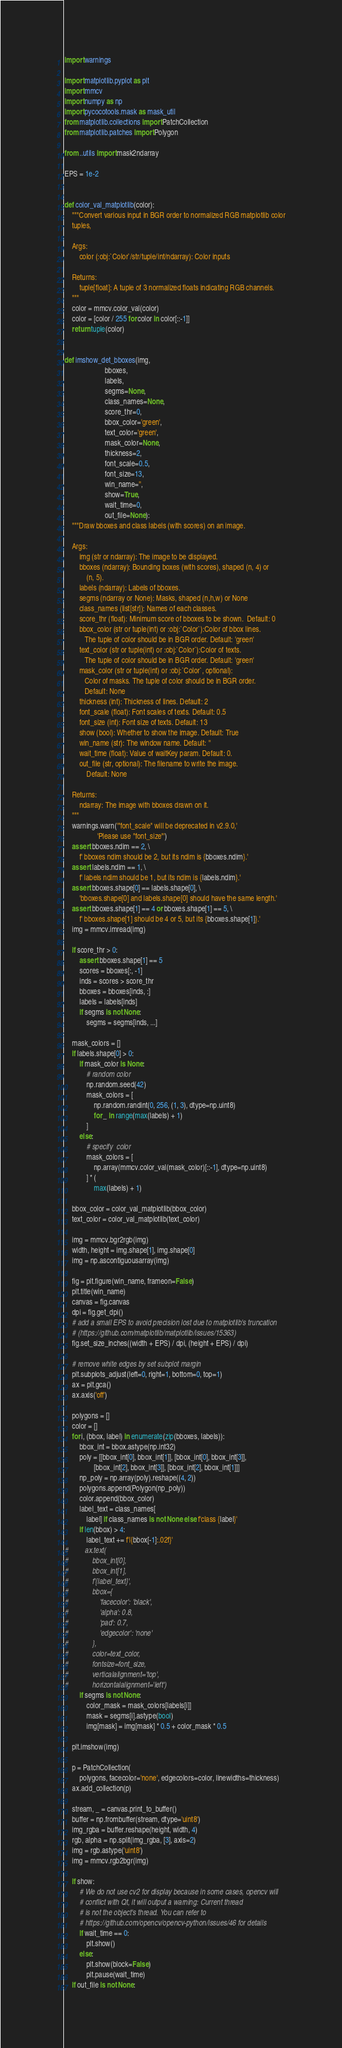Convert code to text. <code><loc_0><loc_0><loc_500><loc_500><_Python_>import warnings

import matplotlib.pyplot as plt
import mmcv
import numpy as np
import pycocotools.mask as mask_util
from matplotlib.collections import PatchCollection
from matplotlib.patches import Polygon

from ..utils import mask2ndarray

EPS = 1e-2


def color_val_matplotlib(color):
    """Convert various input in BGR order to normalized RGB matplotlib color
    tuples,

    Args:
        color (:obj:`Color`/str/tuple/int/ndarray): Color inputs

    Returns:
        tuple[float]: A tuple of 3 normalized floats indicating RGB channels.
    """
    color = mmcv.color_val(color)
    color = [color / 255 for color in color[::-1]]
    return tuple(color)


def imshow_det_bboxes(img,
                      bboxes,
                      labels,
                      segms=None,
                      class_names=None,
                      score_thr=0,
                      bbox_color='green',
                      text_color='green',
                      mask_color=None,
                      thickness=2,
                      font_scale=0.5,
                      font_size=13,
                      win_name='',
                      show=True,
                      wait_time=0,
                      out_file=None):
    """Draw bboxes and class labels (with scores) on an image.

    Args:
        img (str or ndarray): The image to be displayed.
        bboxes (ndarray): Bounding boxes (with scores), shaped (n, 4) or
            (n, 5).
        labels (ndarray): Labels of bboxes.
        segms (ndarray or None): Masks, shaped (n,h,w) or None
        class_names (list[str]): Names of each classes.
        score_thr (float): Minimum score of bboxes to be shown.  Default: 0
        bbox_color (str or tuple(int) or :obj:`Color`):Color of bbox lines.
           The tuple of color should be in BGR order. Default: 'green'
        text_color (str or tuple(int) or :obj:`Color`):Color of texts.
           The tuple of color should be in BGR order. Default: 'green'
        mask_color (str or tuple(int) or :obj:`Color`, optional):
           Color of masks. The tuple of color should be in BGR order.
           Default: None
        thickness (int): Thickness of lines. Default: 2
        font_scale (float): Font scales of texts. Default: 0.5
        font_size (int): Font size of texts. Default: 13
        show (bool): Whether to show the image. Default: True
        win_name (str): The window name. Default: ''
        wait_time (float): Value of waitKey param. Default: 0.
        out_file (str, optional): The filename to write the image.
            Default: None

    Returns:
        ndarray: The image with bboxes drawn on it.
    """
    warnings.warn('"font_scale" will be deprecated in v2.9.0,'
                  'Please use "font_size"')
    assert bboxes.ndim == 2, \
        f' bboxes ndim should be 2, but its ndim is {bboxes.ndim}.'
    assert labels.ndim == 1, \
        f' labels ndim should be 1, but its ndim is {labels.ndim}.'
    assert bboxes.shape[0] == labels.shape[0], \
        'bboxes.shape[0] and labels.shape[0] should have the same length.'
    assert bboxes.shape[1] == 4 or bboxes.shape[1] == 5, \
        f' bboxes.shape[1] should be 4 or 5, but its {bboxes.shape[1]}.'
    img = mmcv.imread(img)

    if score_thr > 0:
        assert bboxes.shape[1] == 5
        scores = bboxes[:, -1]
        inds = scores > score_thr
        bboxes = bboxes[inds, :]
        labels = labels[inds]
        if segms is not None:
            segms = segms[inds, ...]

    mask_colors = []
    if labels.shape[0] > 0:
        if mask_color is None:
            # random color
            np.random.seed(42)
            mask_colors = [
                np.random.randint(0, 256, (1, 3), dtype=np.uint8)
                for _ in range(max(labels) + 1)
            ]
        else:
            # specify  color
            mask_colors = [
                np.array(mmcv.color_val(mask_color)[::-1], dtype=np.uint8)
            ] * (
                max(labels) + 1)

    bbox_color = color_val_matplotlib(bbox_color)
    text_color = color_val_matplotlib(text_color)

    img = mmcv.bgr2rgb(img)
    width, height = img.shape[1], img.shape[0]
    img = np.ascontiguousarray(img)

    fig = plt.figure(win_name, frameon=False)
    plt.title(win_name)
    canvas = fig.canvas
    dpi = fig.get_dpi()
    # add a small EPS to avoid precision lost due to matplotlib's truncation
    # (https://github.com/matplotlib/matplotlib/issues/15363)
    fig.set_size_inches((width + EPS) / dpi, (height + EPS) / dpi)

    # remove white edges by set subplot margin
    plt.subplots_adjust(left=0, right=1, bottom=0, top=1)
    ax = plt.gca()
    ax.axis('off')

    polygons = []
    color = []
    for i, (bbox, label) in enumerate(zip(bboxes, labels)):
        bbox_int = bbox.astype(np.int32)
        poly = [[bbox_int[0], bbox_int[1]], [bbox_int[0], bbox_int[3]],
                [bbox_int[2], bbox_int[3]], [bbox_int[2], bbox_int[1]]]
        np_poly = np.array(poly).reshape((4, 2))
        polygons.append(Polygon(np_poly))
        color.append(bbox_color)
        label_text = class_names[
            label] if class_names is not None else f'class {label}'
        if len(bbox) > 4:
            label_text += f'|{bbox[-1]:.02f}'
#         ax.text(
#             bbox_int[0],
#             bbox_int[1],
#             f'{label_text}',
#             bbox={
#                 'facecolor': 'black',
#                 'alpha': 0.8,
#                 'pad': 0.7,
#                 'edgecolor': 'none'
#             },
#             color=text_color,
#             fontsize=font_size,
#             verticalalignment='top',
#             horizontalalignment='left')
        if segms is not None:
            color_mask = mask_colors[labels[i]]
            mask = segms[i].astype(bool)
            img[mask] = img[mask] * 0.5 + color_mask * 0.5

    plt.imshow(img)

    p = PatchCollection(
        polygons, facecolor='none', edgecolors=color, linewidths=thickness)
    ax.add_collection(p)

    stream, _ = canvas.print_to_buffer()
    buffer = np.frombuffer(stream, dtype='uint8')
    img_rgba = buffer.reshape(height, width, 4)
    rgb, alpha = np.split(img_rgba, [3], axis=2)
    img = rgb.astype('uint8')
    img = mmcv.rgb2bgr(img)

    if show:
        # We do not use cv2 for display because in some cases, opencv will
        # conflict with Qt, it will output a warning: Current thread
        # is not the object's thread. You can refer to
        # https://github.com/opencv/opencv-python/issues/46 for details
        if wait_time == 0:
            plt.show()
        else:
            plt.show(block=False)
            plt.pause(wait_time)
    if out_file is not None:</code> 